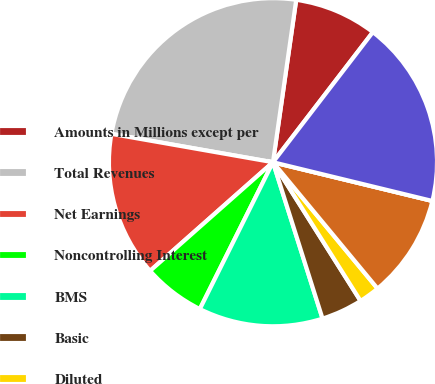Convert chart to OTSL. <chart><loc_0><loc_0><loc_500><loc_500><pie_chart><fcel>Amounts in Millions except per<fcel>Total Revenues<fcel>Net Earnings<fcel>Noncontrolling Interest<fcel>BMS<fcel>Basic<fcel>Diluted<fcel>Cash dividends paid on BMS<fcel>Cash dividends declared per<fcel>Cash and cash equivalents<nl><fcel>8.16%<fcel>24.49%<fcel>14.29%<fcel>6.12%<fcel>12.24%<fcel>4.08%<fcel>2.04%<fcel>10.2%<fcel>0.0%<fcel>18.37%<nl></chart> 